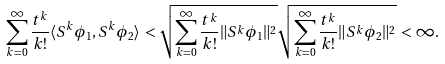Convert formula to latex. <formula><loc_0><loc_0><loc_500><loc_500>\sum _ { k = 0 } ^ { \infty } \frac { t ^ { k } } { k ! } \langle S ^ { k } \phi _ { 1 } , S ^ { k } \phi _ { 2 } \rangle \, < \sqrt { \sum _ { k = 0 } ^ { \infty } \frac { t ^ { k } } { k ! } \| S ^ { k } \phi _ { 1 } \| ^ { 2 } } \sqrt { \sum _ { k = 0 } ^ { \infty } \frac { t ^ { k } } { k ! } \| S ^ { k } \phi _ { 2 } \| ^ { 2 } } \, < \infty .</formula> 